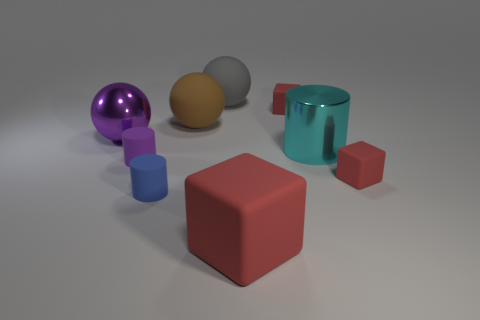Subtract all balls. How many objects are left? 6 Subtract all large purple things. Subtract all tiny matte cylinders. How many objects are left? 6 Add 7 blue cylinders. How many blue cylinders are left? 8 Add 8 big cyan matte blocks. How many big cyan matte blocks exist? 8 Subtract 0 brown blocks. How many objects are left? 9 